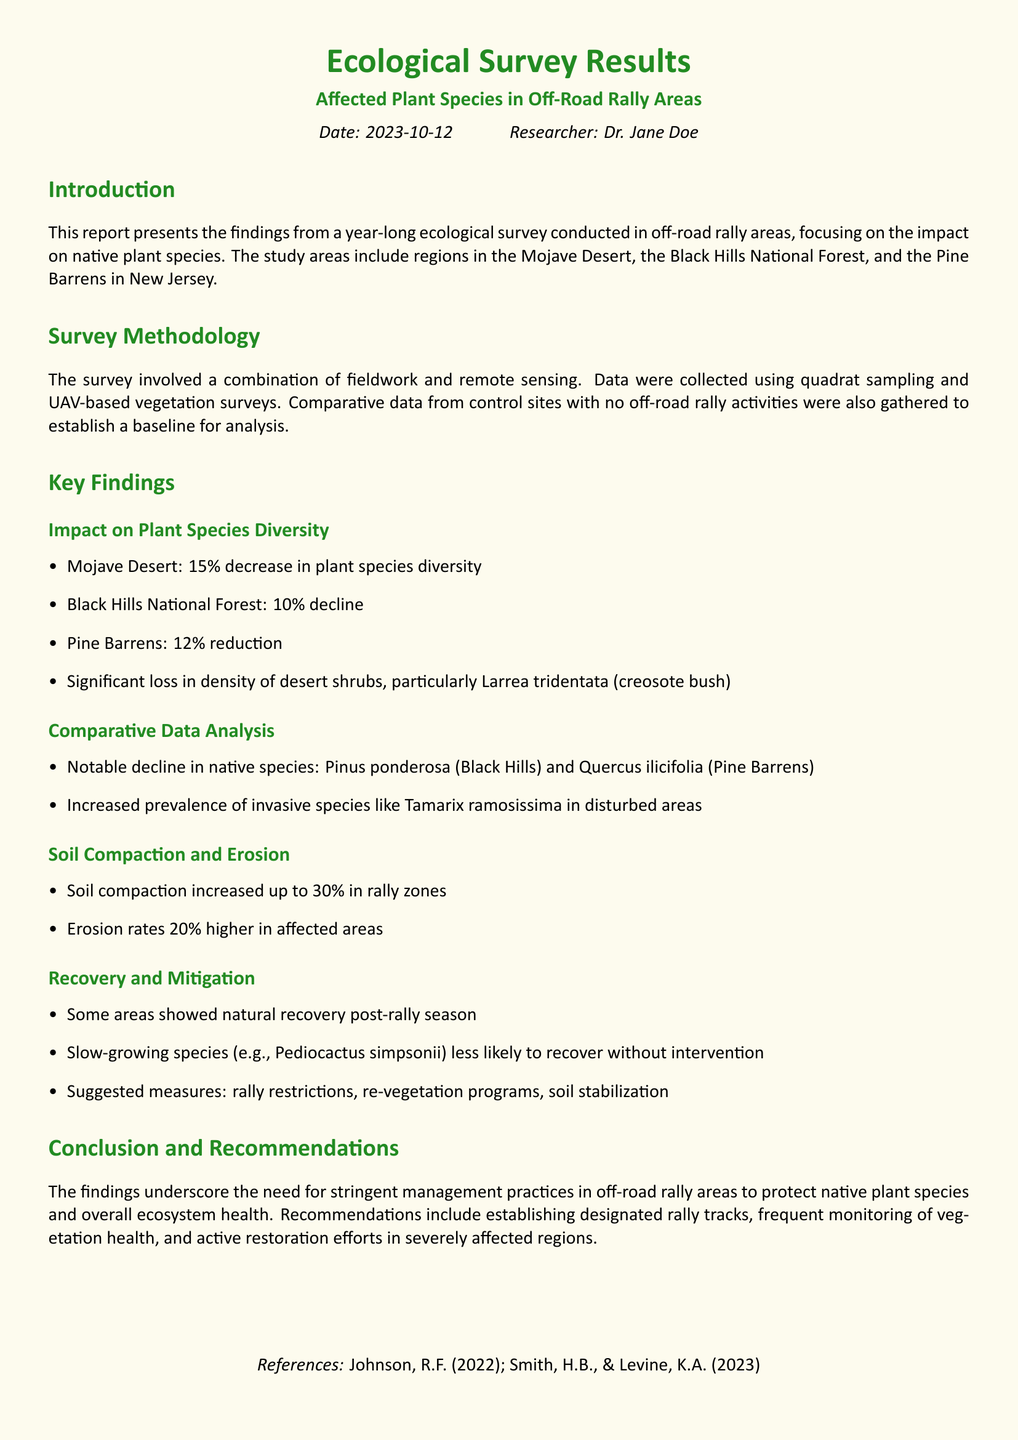What is the date of the report? The date of the report is provided in the introduction section.
Answer: 2023-10-12 What is the name of the researcher? The researcher's name is mentioned in the introduction section of the document.
Answer: Dr. Jane Doe Which plant species showed significant loss in density? The key findings mention a specific plant species that experienced a loss in density due to the impact of off-road rallies.
Answer: Larrea tridentata What was the percentage decrease in plant species diversity in the Mojave Desert? The key findings section provides specific percentage decreases for plant species diversity across different areas.
Answer: 15% What measures are suggested for recovery? The conclusion and recommendations section lists specific measures that could help in the recovery of affected areas.
Answer: rally restrictions, re-vegetation programs, soil stabilization What is the increase in soil compaction in rally zones? The document details the change in soil compaction due to the rallies, indicating a specific percentage increase.
Answer: 30% What invasive species increased in disturbed areas? The key findings section mentions a particular invasive species prevalent in disturbed areas as a result of off-road activities.
Answer: Tamarix ramosissima Which area had a 10% decline in plant species diversity? The survey results include comparative data that highlight the percentage declines in different regions.
Answer: Black Hills National Forest What are the erosion rates in affected areas? The document provides statistics on how the erosion rates changed in affected areas compared to control sites.
Answer: 20% higher 